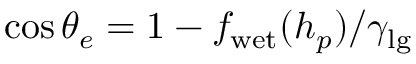<formula> <loc_0><loc_0><loc_500><loc_500>\cos \theta _ { e } = 1 - f _ { w e t } ( h _ { p } ) / \gamma _ { l g }</formula> 